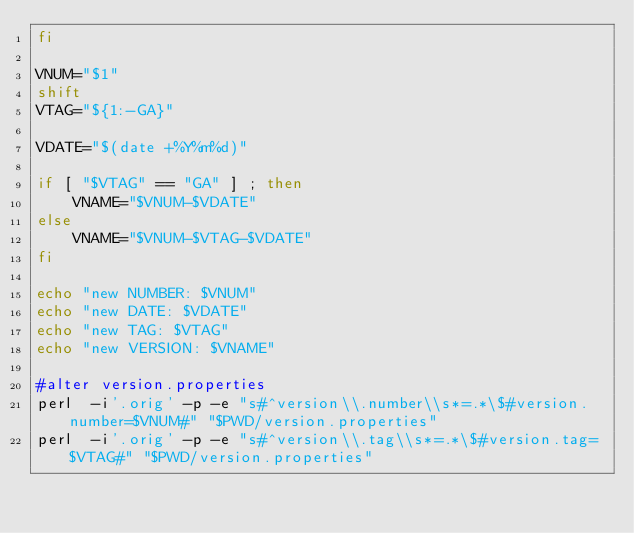Convert code to text. <code><loc_0><loc_0><loc_500><loc_500><_Bash_>fi

VNUM="$1"
shift
VTAG="${1:-GA}"

VDATE="$(date +%Y%m%d)"

if [ "$VTAG" == "GA" ] ; then
	VNAME="$VNUM-$VDATE"
else
	VNAME="$VNUM-$VTAG-$VDATE"
fi

echo "new NUMBER: $VNUM"
echo "new DATE: $VDATE"
echo "new TAG: $VTAG"
echo "new VERSION: $VNAME"

#alter version.properties
perl  -i'.orig' -p -e "s#^version\\.number\\s*=.*\$#version.number=$VNUM#" "$PWD/version.properties"
perl  -i'.orig' -p -e "s#^version\\.tag\\s*=.*\$#version.tag=$VTAG#" "$PWD/version.properties"</code> 